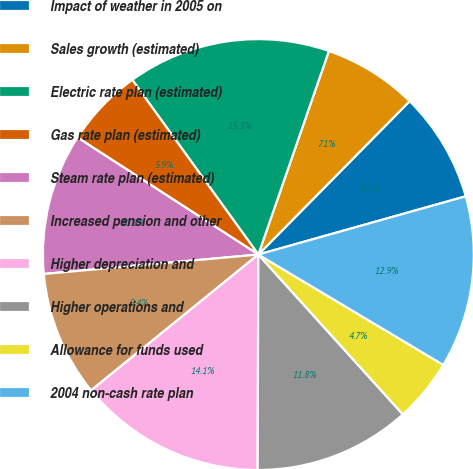Convert chart. <chart><loc_0><loc_0><loc_500><loc_500><pie_chart><fcel>Impact of weather in 2005 on<fcel>Sales growth (estimated)<fcel>Electric rate plan (estimated)<fcel>Gas rate plan (estimated)<fcel>Steam rate plan (estimated)<fcel>Increased pension and other<fcel>Higher depreciation and<fcel>Higher operations and<fcel>Allowance for funds used<fcel>2004 non-cash rate plan<nl><fcel>8.25%<fcel>7.08%<fcel>15.26%<fcel>5.91%<fcel>10.58%<fcel>9.42%<fcel>14.09%<fcel>11.75%<fcel>4.74%<fcel>12.92%<nl></chart> 